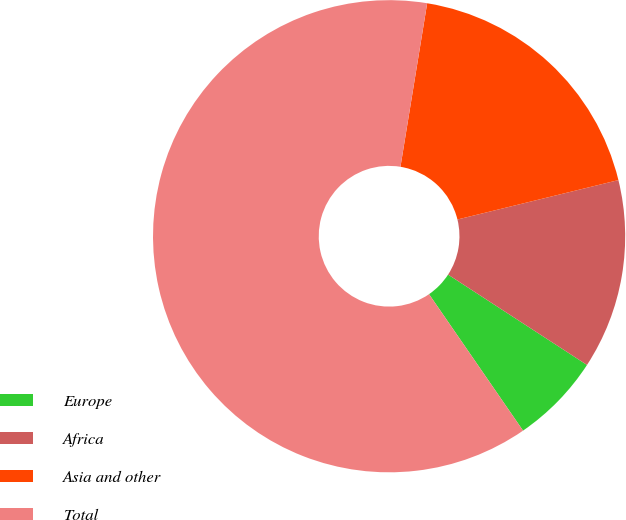<chart> <loc_0><loc_0><loc_500><loc_500><pie_chart><fcel>Europe<fcel>Africa<fcel>Asia and other<fcel>Total<nl><fcel>6.22%<fcel>13.0%<fcel>18.6%<fcel>62.18%<nl></chart> 